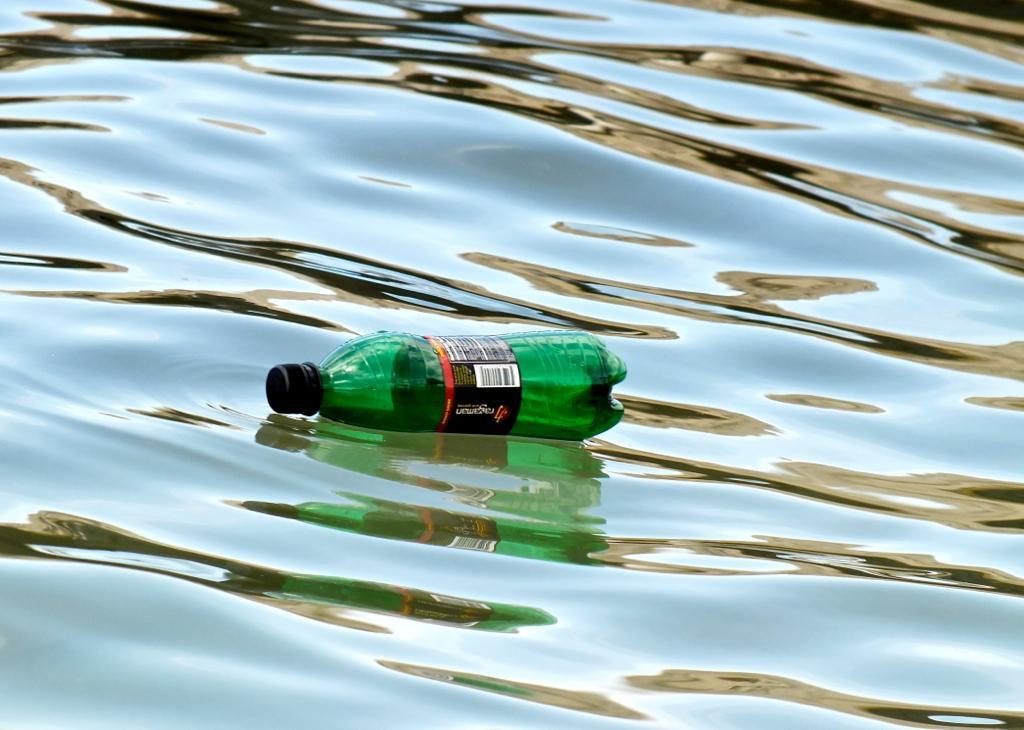Please provide a concise description of this image. In this picture we can see a bottle in the water. 